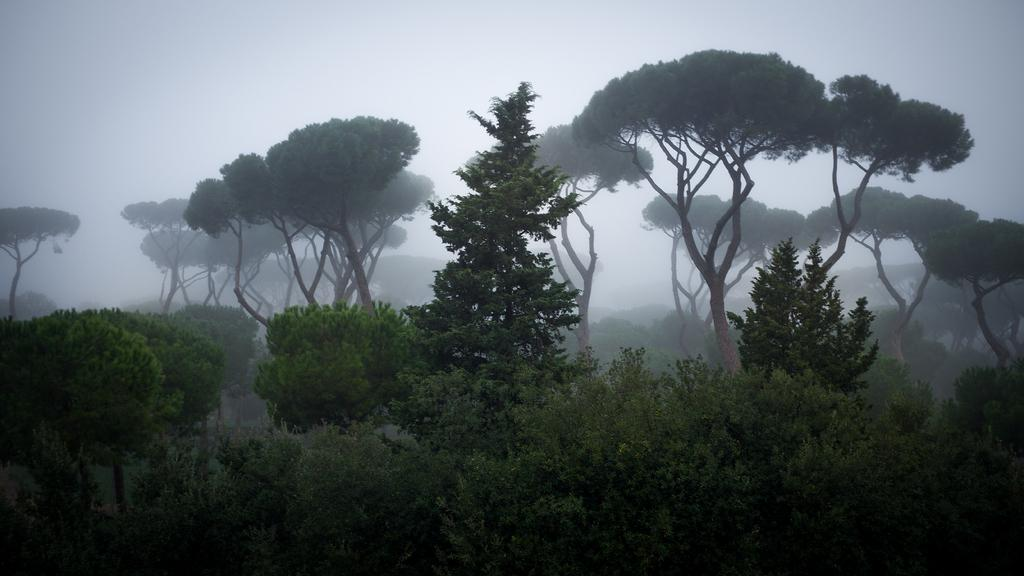What type of environment might the image be taken from? The image might be taken from a forest. What can be seen in the image that is characteristic of a forest? There are trees and plants in the image. What is visible in the background of the image? The sky is visible in the image. How would you describe the weather based on the sky in the image? The sky is cloudy in the image. What type of sign can be seen in the image? There is no sign present in the image. What books are visible on the ground in the image? There are no books visible in the image. 